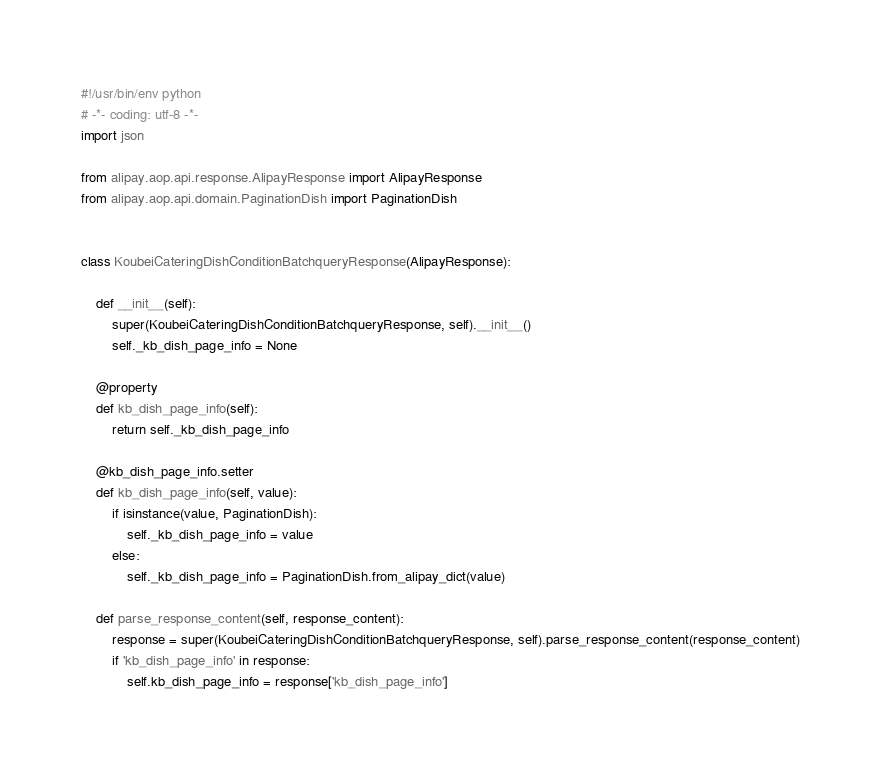Convert code to text. <code><loc_0><loc_0><loc_500><loc_500><_Python_>#!/usr/bin/env python
# -*- coding: utf-8 -*-
import json

from alipay.aop.api.response.AlipayResponse import AlipayResponse
from alipay.aop.api.domain.PaginationDish import PaginationDish


class KoubeiCateringDishConditionBatchqueryResponse(AlipayResponse):

    def __init__(self):
        super(KoubeiCateringDishConditionBatchqueryResponse, self).__init__()
        self._kb_dish_page_info = None

    @property
    def kb_dish_page_info(self):
        return self._kb_dish_page_info

    @kb_dish_page_info.setter
    def kb_dish_page_info(self, value):
        if isinstance(value, PaginationDish):
            self._kb_dish_page_info = value
        else:
            self._kb_dish_page_info = PaginationDish.from_alipay_dict(value)

    def parse_response_content(self, response_content):
        response = super(KoubeiCateringDishConditionBatchqueryResponse, self).parse_response_content(response_content)
        if 'kb_dish_page_info' in response:
            self.kb_dish_page_info = response['kb_dish_page_info']
</code> 